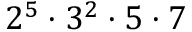Convert formula to latex. <formula><loc_0><loc_0><loc_500><loc_500>2 ^ { 5 } \cdot 3 ^ { 2 } \cdot 5 \cdot 7</formula> 